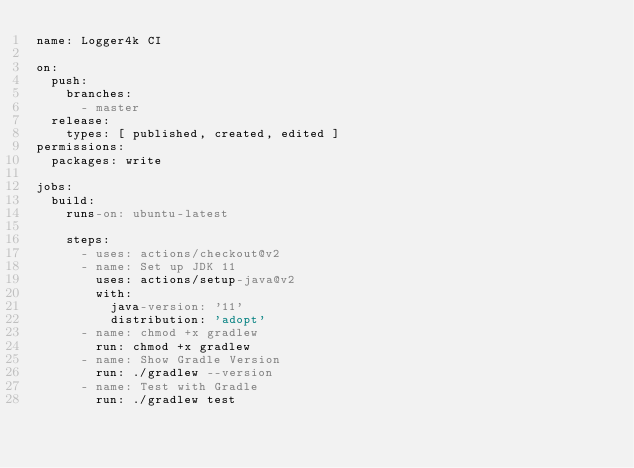<code> <loc_0><loc_0><loc_500><loc_500><_YAML_>name: Logger4k CI

on:
  push:
    branches:
      - master
  release:
    types: [ published, created, edited ]
permissions:
  packages: write

jobs:
  build:
    runs-on: ubuntu-latest

    steps:
      - uses: actions/checkout@v2
      - name: Set up JDK 11
        uses: actions/setup-java@v2
        with:
          java-version: '11'
          distribution: 'adopt'
      - name: chmod +x gradlew
        run: chmod +x gradlew
      - name: Show Gradle Version
        run: ./gradlew --version
      - name: Test with Gradle
        run: ./gradlew test

</code> 